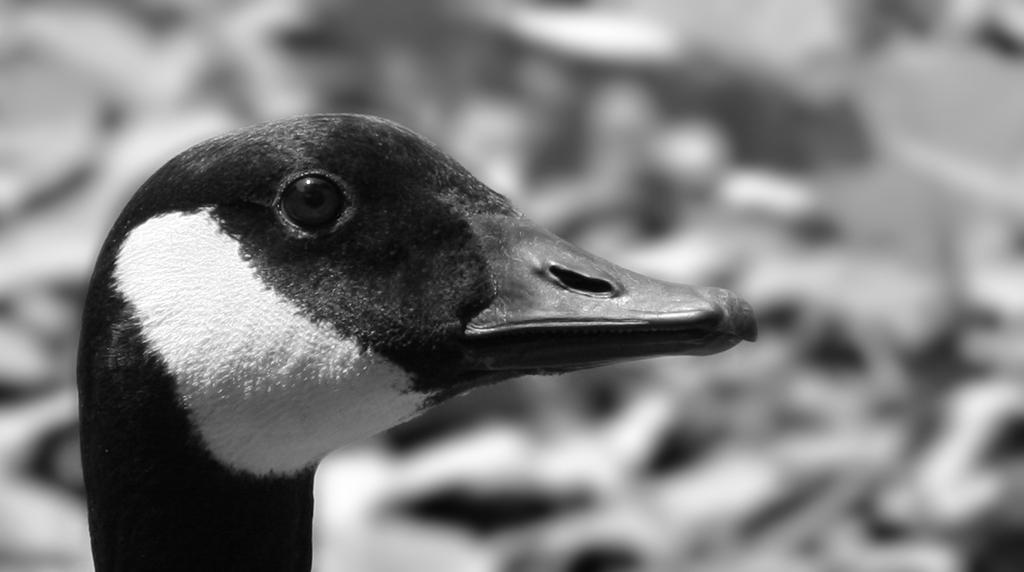What is the color scheme of the image? The image is black and white. What is the main subject in the image? There is a bird face in the front of the image. How would you describe the background of the image? The background of the image is blurry. How does the bird face react to the sound of the cannon in the image? There is no cannon present in the image, so the bird face does not react to any sound. 